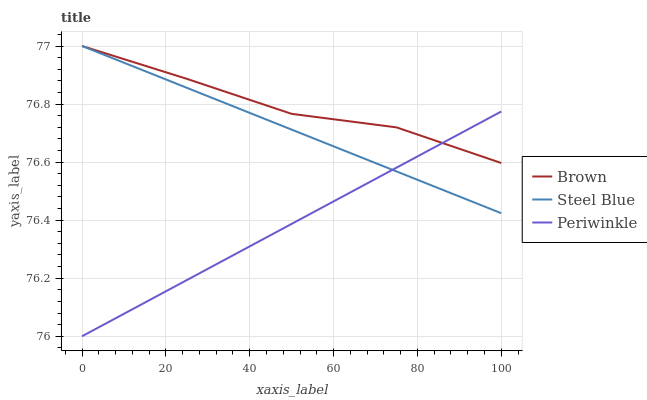Does Steel Blue have the minimum area under the curve?
Answer yes or no. No. Does Steel Blue have the maximum area under the curve?
Answer yes or no. No. Is Periwinkle the smoothest?
Answer yes or no. No. Is Periwinkle the roughest?
Answer yes or no. No. Does Steel Blue have the lowest value?
Answer yes or no. No. Does Periwinkle have the highest value?
Answer yes or no. No. 